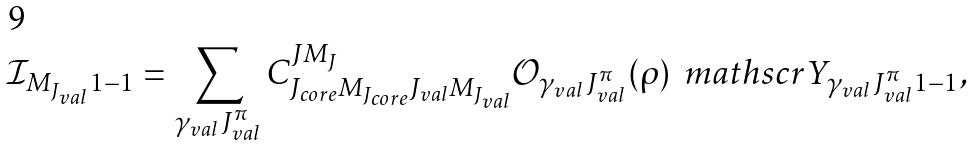<formula> <loc_0><loc_0><loc_500><loc_500>\mathcal { I } _ { M _ { J _ { v a l } } 1 - 1 } = \sum _ { \gamma _ { v a l } \, J _ { v a l } ^ { \pi } } C _ { J _ { c o r e } M _ { J _ { c o r e } } J _ { v a l } M _ { J _ { v a l } } } ^ { J M _ { J } } \mathcal { O } _ { \gamma _ { v a l } \, J _ { v a l } ^ { \pi } } ( \rho ) \, \ m a t h s c r { Y } _ { \gamma _ { v a l } \, J _ { v a l } ^ { \pi } 1 - 1 } ,</formula> 